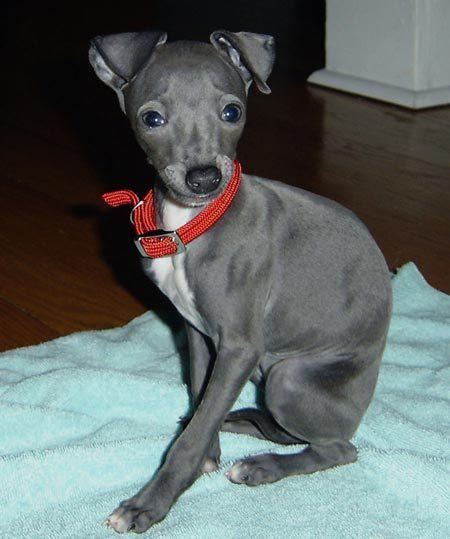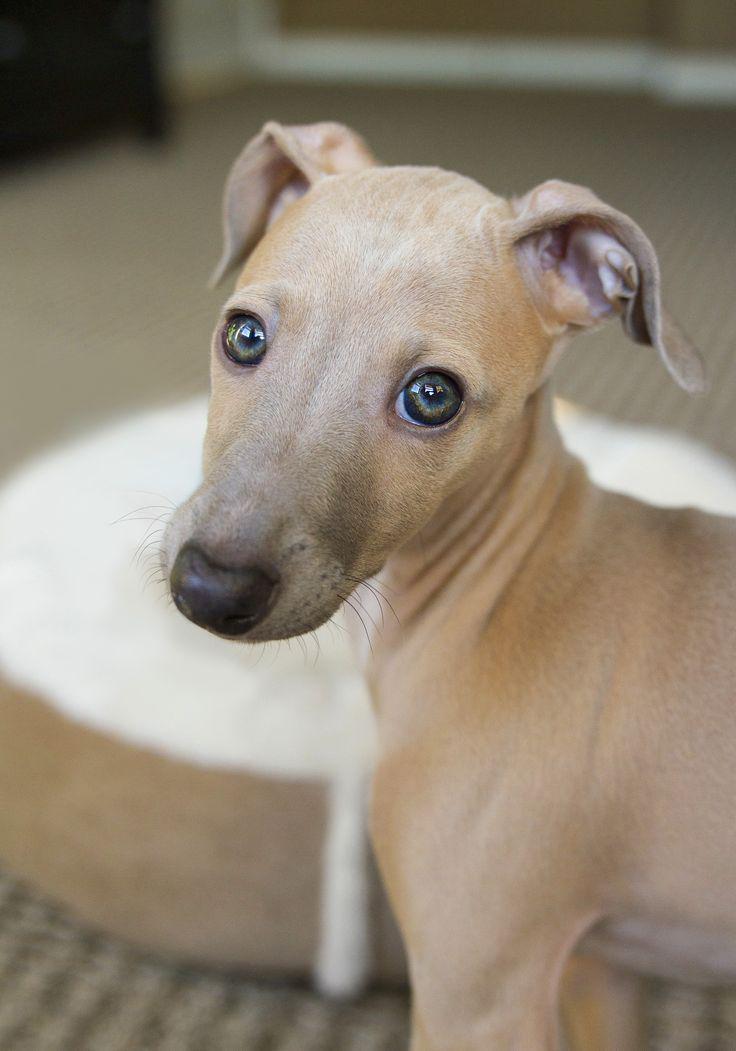The first image is the image on the left, the second image is the image on the right. Assess this claim about the two images: "The right image contains at least one dog wearing a collar.". Correct or not? Answer yes or no. No. The first image is the image on the left, the second image is the image on the right. Given the left and right images, does the statement "At least one dog in the image on the right is wearing a collar." hold true? Answer yes or no. No. 